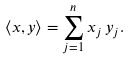Convert formula to latex. <formula><loc_0><loc_0><loc_500><loc_500>\langle x , y \rangle = \sum _ { j = 1 } ^ { n } x _ { j } \, y _ { j } .</formula> 